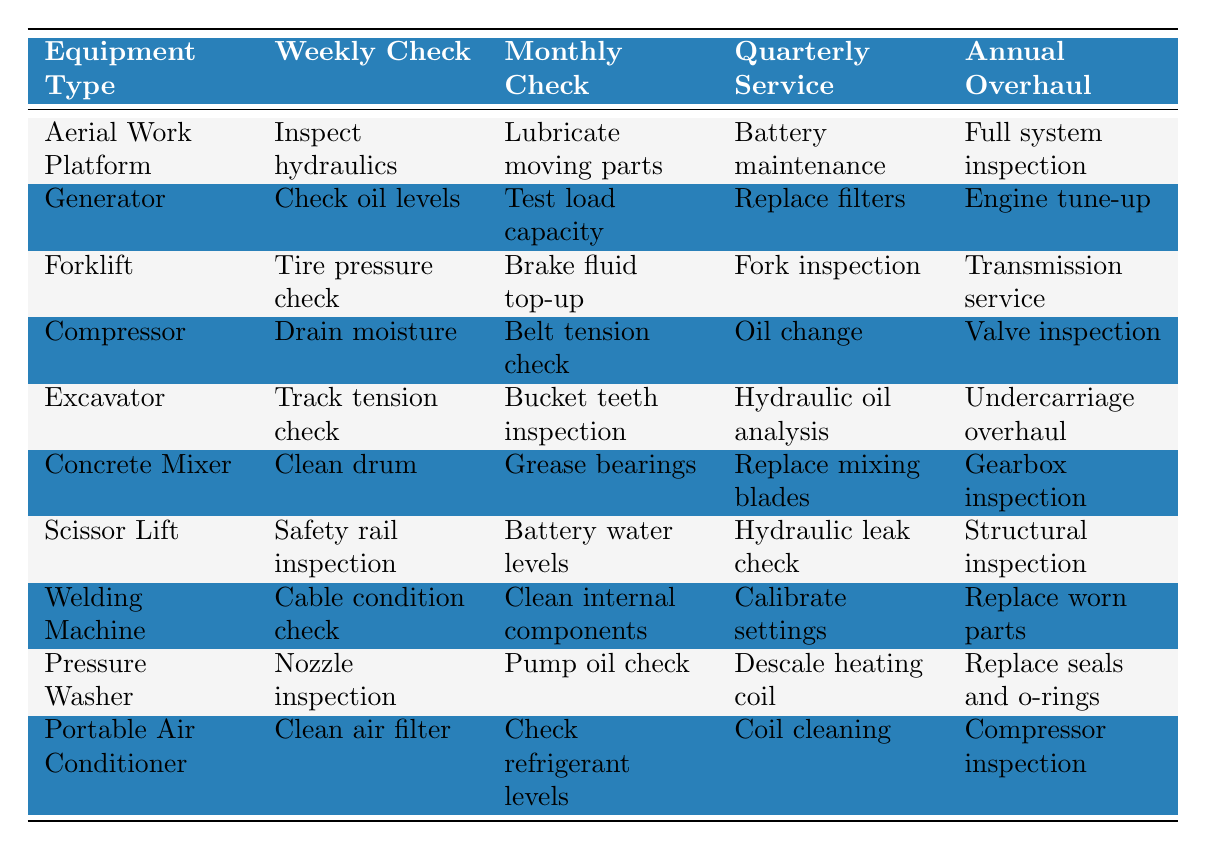What are the weekly checks for the Generator? The table shows that the weekly check for the Generator is to "Check oil levels."
Answer: Check oil levels Which equipment type requires a hydraulic oil analysis during quarterly service? The table indicates that the Excavator requires a hydraulic oil analysis as part of its quarterly service.
Answer: Excavator Is there a monthly check for the Scissor Lift? Yes, the monthly check for the Scissor Lift is to check the battery water levels.
Answer: Yes What equipment type has cleaning tasks for both monthly and annual checks? The Concrete Mixer has cleaning tasks listed for monthly (Grease bearings) and annual checks (Gearbox inspection).
Answer: Concrete Mixer For which equipment is the hydraulic leak check performed? The table shows that the Scissor Lift includes hydraulic leak check as a quarterly service task.
Answer: Scissor Lift Which equipment type has the highest number of tasks listed? Each equipment type has four tasks listed, so none has a higher number than others.
Answer: None What is the annual overhaul check for the Portable Air Conditioner? The annual overhaul check for the Portable Air Conditioner is "Compressor inspection."
Answer: Compressor inspection Do both the Forklift and the Excavator require a check for part inspection? Yes, both require inspection checks; Forklift has a fork inspection, while Excavator has a bucket teeth inspection.
Answer: Yes Which type of equipment does not have a lubrication task listed in its checks? The Welding Machine does not have any lubrication task listed among its checks.
Answer: Welding Machine What is the difference between the tasks in the monthly checks for the Aerial Work Platform and the Compressor? The Aerial Work Platform has "Lubricate moving parts," while the Compressor has "Belt tension check," resulting in a difference of focus on lubrication versus mechanical adjustment.
Answer: Aerial Work Platform focuses on lubrication; Compressor on mechanical adjustment 